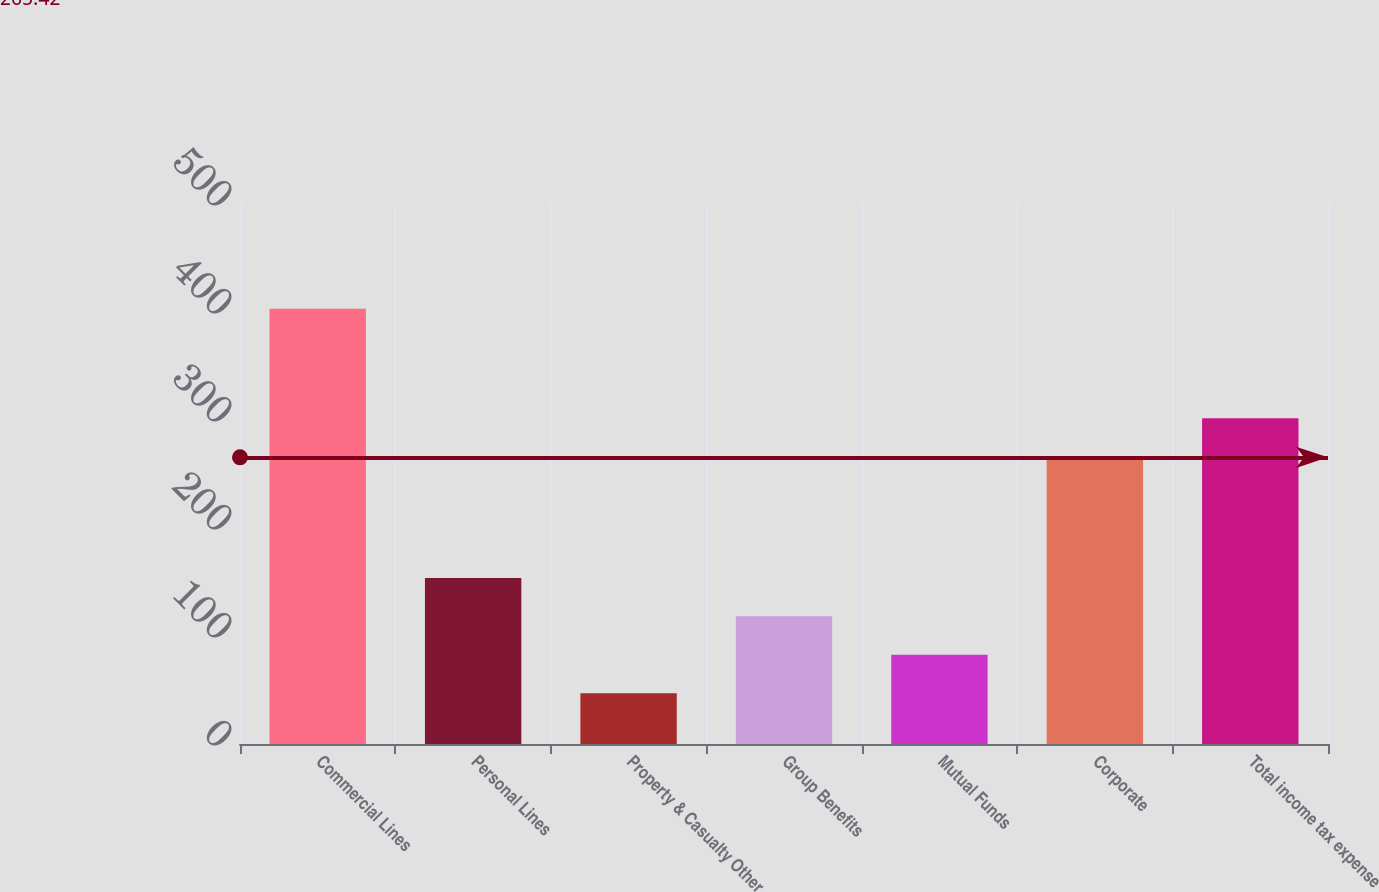Convert chart to OTSL. <chart><loc_0><loc_0><loc_500><loc_500><bar_chart><fcel>Commercial Lines<fcel>Personal Lines<fcel>Property & Casualty Other<fcel>Group Benefits<fcel>Mutual Funds<fcel>Corporate<fcel>Total income tax expense<nl><fcel>403<fcel>153.8<fcel>47<fcel>118.2<fcel>82.6<fcel>266<fcel>301.6<nl></chart> 